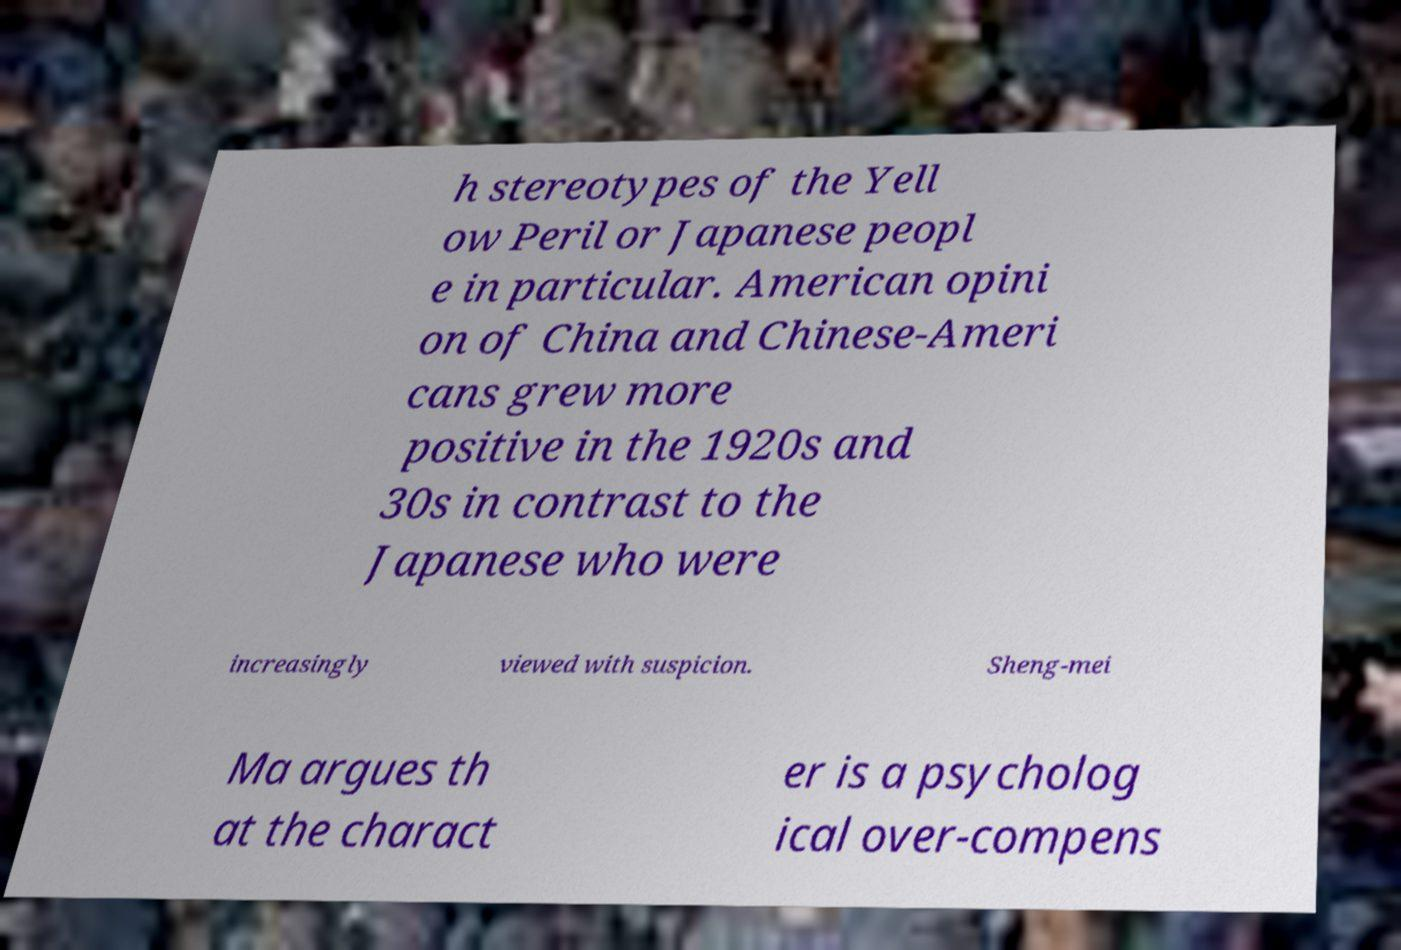Please read and relay the text visible in this image. What does it say? h stereotypes of the Yell ow Peril or Japanese peopl e in particular. American opini on of China and Chinese-Ameri cans grew more positive in the 1920s and 30s in contrast to the Japanese who were increasingly viewed with suspicion. Sheng-mei Ma argues th at the charact er is a psycholog ical over-compens 